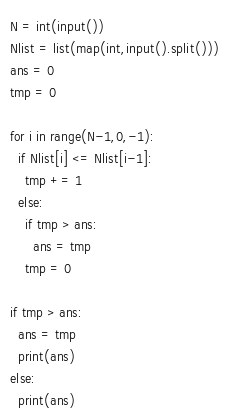Convert code to text. <code><loc_0><loc_0><loc_500><loc_500><_Python_>N = int(input())
Nlist = list(map(int,input().split()))
ans = 0
tmp = 0

for i in range(N-1,0,-1):
  if Nlist[i] <= Nlist[i-1]:
    tmp += 1
  else:
    if tmp > ans:
      ans = tmp
    tmp = 0

if tmp > ans:
  ans = tmp
  print(ans)
else:
  print(ans)</code> 